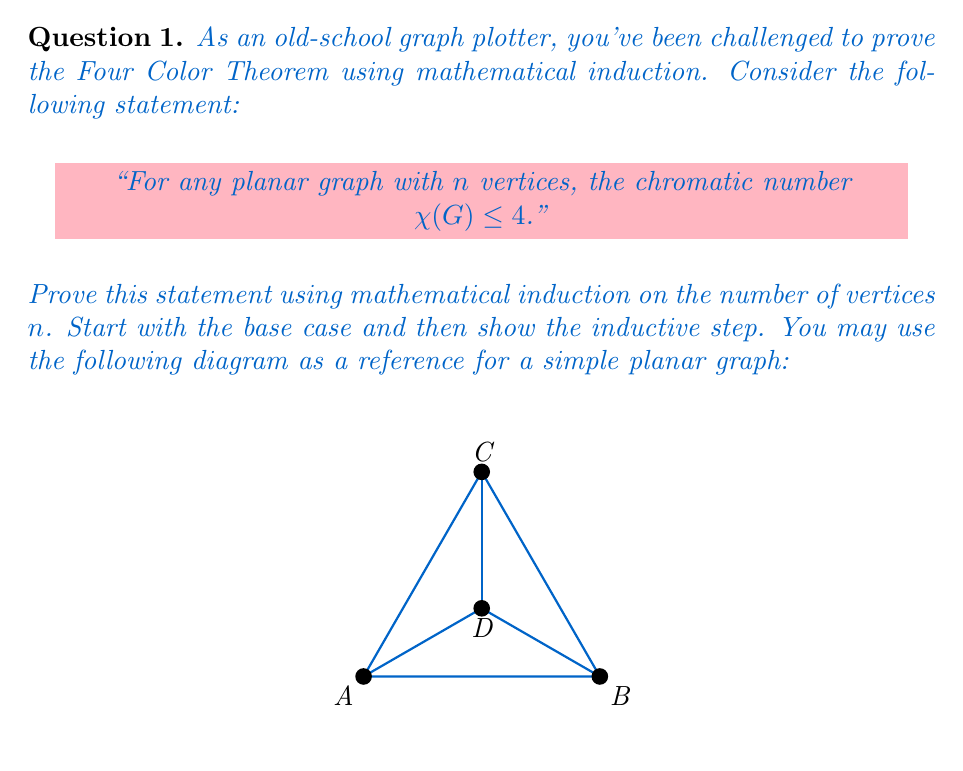Solve this math problem. To prove the Four Color Theorem using mathematical induction, we'll follow these steps:

1. Base case: 
Let's start with $n = 1$, $2$, $3$, and $4$ vertices.
- For $n = 1$, a single vertex can be colored with one color.
- For $n = 2$, two vertices connected by an edge can be colored with two colors.
- For $n = 3$, a triangle can be colored with three colors.
- For $n = 4$, a planar graph (like the tetrahedron) can be colored with four colors.

Therefore, the base cases hold as $\chi(G) \leq 4$ for $n \leq 4$.

2. Inductive hypothesis:
Assume the statement is true for all planar graphs with $k$ vertices, where $k \geq 4$. That is, $\chi(G_k) \leq 4$ for any planar graph $G_k$ with $k$ vertices.

3. Inductive step:
We need to prove that the statement holds for $k+1$ vertices. Consider a planar graph $G_{k+1}$ with $k+1$ vertices.

a) If $G_{k+1}$ has a vertex $v$ with degree $\leq 3$, remove $v$ to get a graph $G_k$ with $k$ vertices. By the inductive hypothesis, $G_k$ can be colored with at most 4 colors.

b) Now, add $v$ back to $G_k$. Since $v$ has at most 3 neighbors, there will always be at least one color available to color $v$ without conflicts.

c) If all vertices in $G_{k+1}$ have degree $\geq 4$, we can use Euler's formula:
   $V - E + F = 2$, where $V$ is the number of vertices, $E$ is the number of edges, and $F$ is the number of faces.

   Since each face has at least 3 edges and each edge is counted twice (once for each face it borders), we have:
   $3F \leq 2E$

   Substituting this into Euler's formula:
   $V - E + \frac{2E}{3} \geq 2$
   $3V - E \geq 6$

   The sum of all vertex degrees equals $2E$, so the average degree is:
   $\frac{2E}{V} < 6$

   This implies that there must be a vertex with degree $< 6$. Remove this vertex and its incident edges to get a graph $G_k$ with $k$ vertices.

d) By the inductive hypothesis, $G_k$ can be colored with at most 4 colors. When we add back the removed vertex, it has at most 5 neighbors, so there will always be at least one color available to color it without conflicts.

Therefore, $\chi(G_{k+1}) \leq 4$, completing the inductive step.

By the principle of mathematical induction, we have proved that for any planar graph with $n$ vertices, $\chi(G) \leq 4$.
Answer: The Four Color Theorem holds for all planar graphs by mathematical induction. 